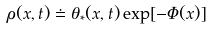<formula> <loc_0><loc_0><loc_500><loc_500>\rho ( x , t ) \doteq \theta _ { * } ( x , t ) \exp [ - \Phi ( x ) ]</formula> 